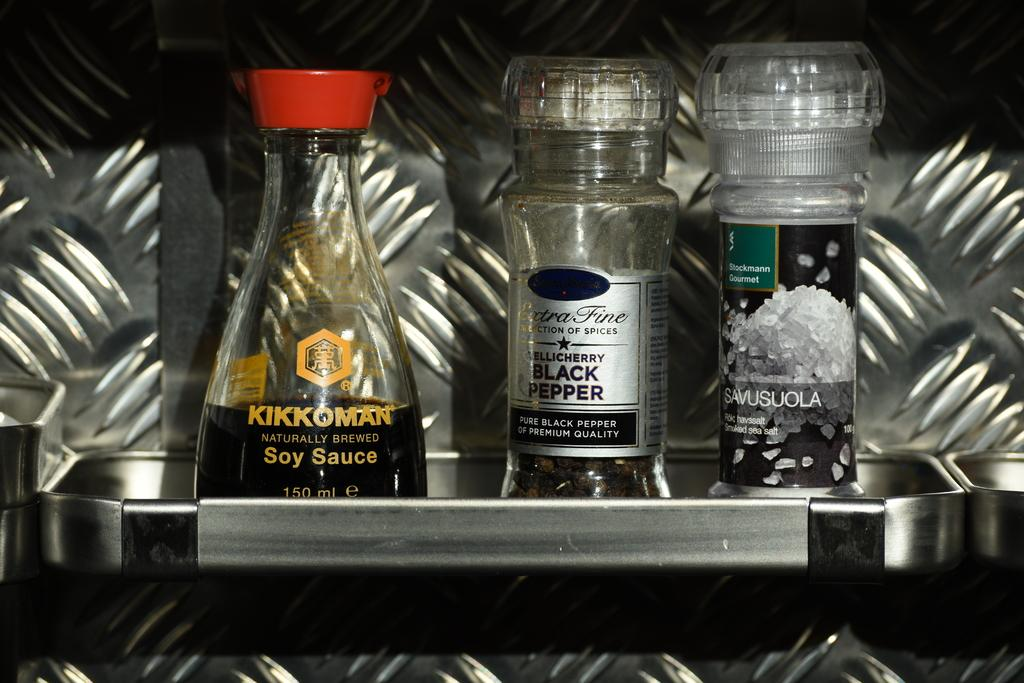Provide a one-sentence caption for the provided image. a trio of food enhancers, including KIKKOMAN Soy Sauce, Extra Fine Black Pepper and SAVUSUOLA smoked sea salt. 